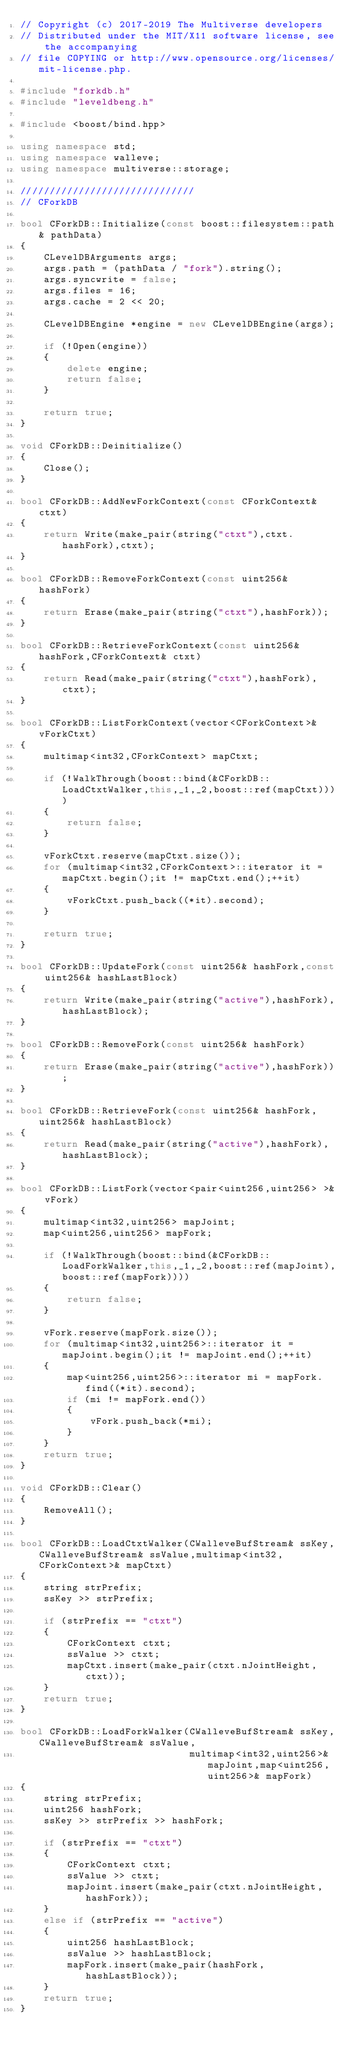Convert code to text. <code><loc_0><loc_0><loc_500><loc_500><_C++_>// Copyright (c) 2017-2019 The Multiverse developers
// Distributed under the MIT/X11 software license, see the accompanying
// file COPYING or http://www.opensource.org/licenses/mit-license.php.
    
#include "forkdb.h"
#include "leveldbeng.h"

#include <boost/bind.hpp>

using namespace std;
using namespace walleve;
using namespace multiverse::storage;
    
//////////////////////////////
// CForkDB

bool CForkDB::Initialize(const boost::filesystem::path& pathData)
{
    CLevelDBArguments args;
    args.path = (pathData / "fork").string();
    args.syncwrite = false;
    args.files = 16;
    args.cache = 2 << 20;

    CLevelDBEngine *engine = new CLevelDBEngine(args);

    if (!Open(engine))
    {
        delete engine;
        return false;
    }

    return true;
}

void CForkDB::Deinitialize()
{
    Close();
}

bool CForkDB::AddNewForkContext(const CForkContext& ctxt)
{
    return Write(make_pair(string("ctxt"),ctxt.hashFork),ctxt);
}

bool CForkDB::RemoveForkContext(const uint256& hashFork)
{
    return Erase(make_pair(string("ctxt"),hashFork));
}

bool CForkDB::RetrieveForkContext(const uint256& hashFork,CForkContext& ctxt)
{
    return Read(make_pair(string("ctxt"),hashFork),ctxt);
}

bool CForkDB::ListForkContext(vector<CForkContext>& vForkCtxt)
{
    multimap<int32,CForkContext> mapCtxt;

    if (!WalkThrough(boost::bind(&CForkDB::LoadCtxtWalker,this,_1,_2,boost::ref(mapCtxt))))
    {
        return false;
    }

    vForkCtxt.reserve(mapCtxt.size());
    for (multimap<int32,CForkContext>::iterator it = mapCtxt.begin();it != mapCtxt.end();++it)
    {
        vForkCtxt.push_back((*it).second);
    } 

    return true;
}

bool CForkDB::UpdateFork(const uint256& hashFork,const uint256& hashLastBlock)
{
    return Write(make_pair(string("active"),hashFork),hashLastBlock);
}

bool CForkDB::RemoveFork(const uint256& hashFork)
{
    return Erase(make_pair(string("active"),hashFork));
}

bool CForkDB::RetrieveFork(const uint256& hashFork,uint256& hashLastBlock)
{
    return Read(make_pair(string("active"),hashFork),hashLastBlock);
}

bool CForkDB::ListFork(vector<pair<uint256,uint256> >& vFork)
{
    multimap<int32,uint256> mapJoint;
    map<uint256,uint256> mapFork;

    if (!WalkThrough(boost::bind(&CForkDB::LoadForkWalker,this,_1,_2,boost::ref(mapJoint),boost::ref(mapFork))))
    {
        return false;
    }

    vFork.reserve(mapFork.size());
    for (multimap<int32,uint256>::iterator it = mapJoint.begin();it != mapJoint.end();++it)
    {
        map<uint256,uint256>::iterator mi = mapFork.find((*it).second);
        if (mi != mapFork.end())
        {
            vFork.push_back(*mi);
        }
    }
    return true;
}

void CForkDB::Clear()
{
    RemoveAll();
}

bool CForkDB::LoadCtxtWalker(CWalleveBufStream& ssKey,CWalleveBufStream& ssValue,multimap<int32,CForkContext>& mapCtxt)
{
    string strPrefix;
    ssKey >> strPrefix;

    if (strPrefix == "ctxt")
    {
        CForkContext ctxt;
        ssValue >> ctxt;
        mapCtxt.insert(make_pair(ctxt.nJointHeight,ctxt));
    }
    return true;
}

bool CForkDB::LoadForkWalker(CWalleveBufStream& ssKey,CWalleveBufStream& ssValue,
                             multimap<int32,uint256>& mapJoint,map<uint256,uint256>& mapFork)
{
    string strPrefix;
    uint256 hashFork;
    ssKey >> strPrefix >> hashFork;

    if (strPrefix == "ctxt")
    {
        CForkContext ctxt;
        ssValue >> ctxt;
        mapJoint.insert(make_pair(ctxt.nJointHeight,hashFork));
    }
    else if (strPrefix == "active")
    {
        uint256 hashLastBlock;
        ssValue >> hashLastBlock;
        mapFork.insert(make_pair(hashFork,hashLastBlock));
    }
    return true;
}

</code> 